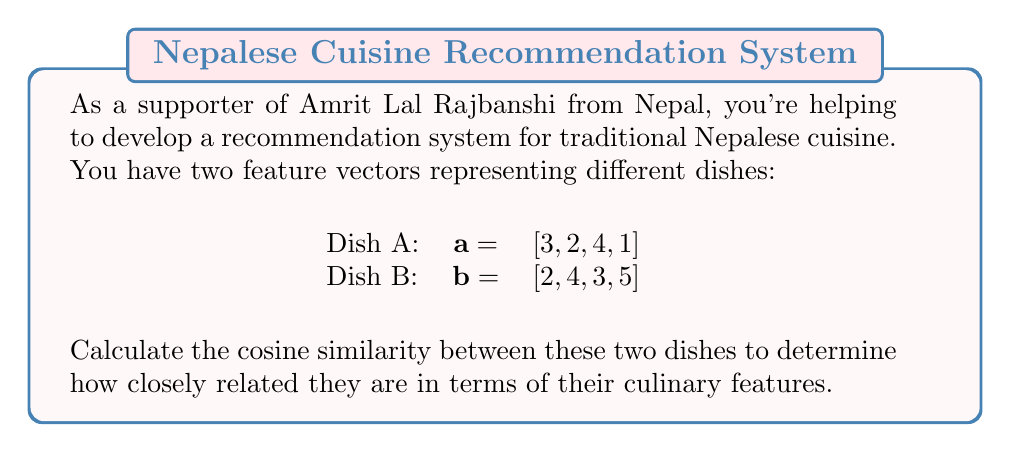Provide a solution to this math problem. To calculate the cosine similarity between two feature vectors, we'll follow these steps:

1. Calculate the dot product of the two vectors:
   $$\text{Dot Product} = \sum_{i=1}^n A_i \cdot B_i$$
   $$(3 \cdot 2) + (2 \cdot 4) + (4 \cdot 3) + (1 \cdot 5) = 6 + 8 + 12 + 5 = 31$$

2. Calculate the magnitude (Euclidean norm) of each vector:
   $$\|A\| = \sqrt{\sum_{i=1}^n A_i^2}$$
   $$\|A\| = \sqrt{3^2 + 2^2 + 4^2 + 1^2} = \sqrt{9 + 4 + 16 + 1} = \sqrt{30} \approx 5.477$$
   
   $$\|B\| = \sqrt{2^2 + 4^2 + 3^2 + 5^2} = \sqrt{4 + 16 + 9 + 25} = \sqrt{54} \approx 7.348$$

3. Apply the cosine similarity formula:
   $$\text{Cosine Similarity} = \frac{\text{Dot Product}}{\|A\| \cdot \|B\|}$$
   
   $$\text{Cosine Similarity} = \frac{31}{5.477 \cdot 7.348} \approx 0.7692$$

The cosine similarity ranges from -1 to 1, where 1 indicates perfect similarity, 0 indicates no correlation, and -1 indicates perfect dissimilarity.
Answer: $0.7692$ 